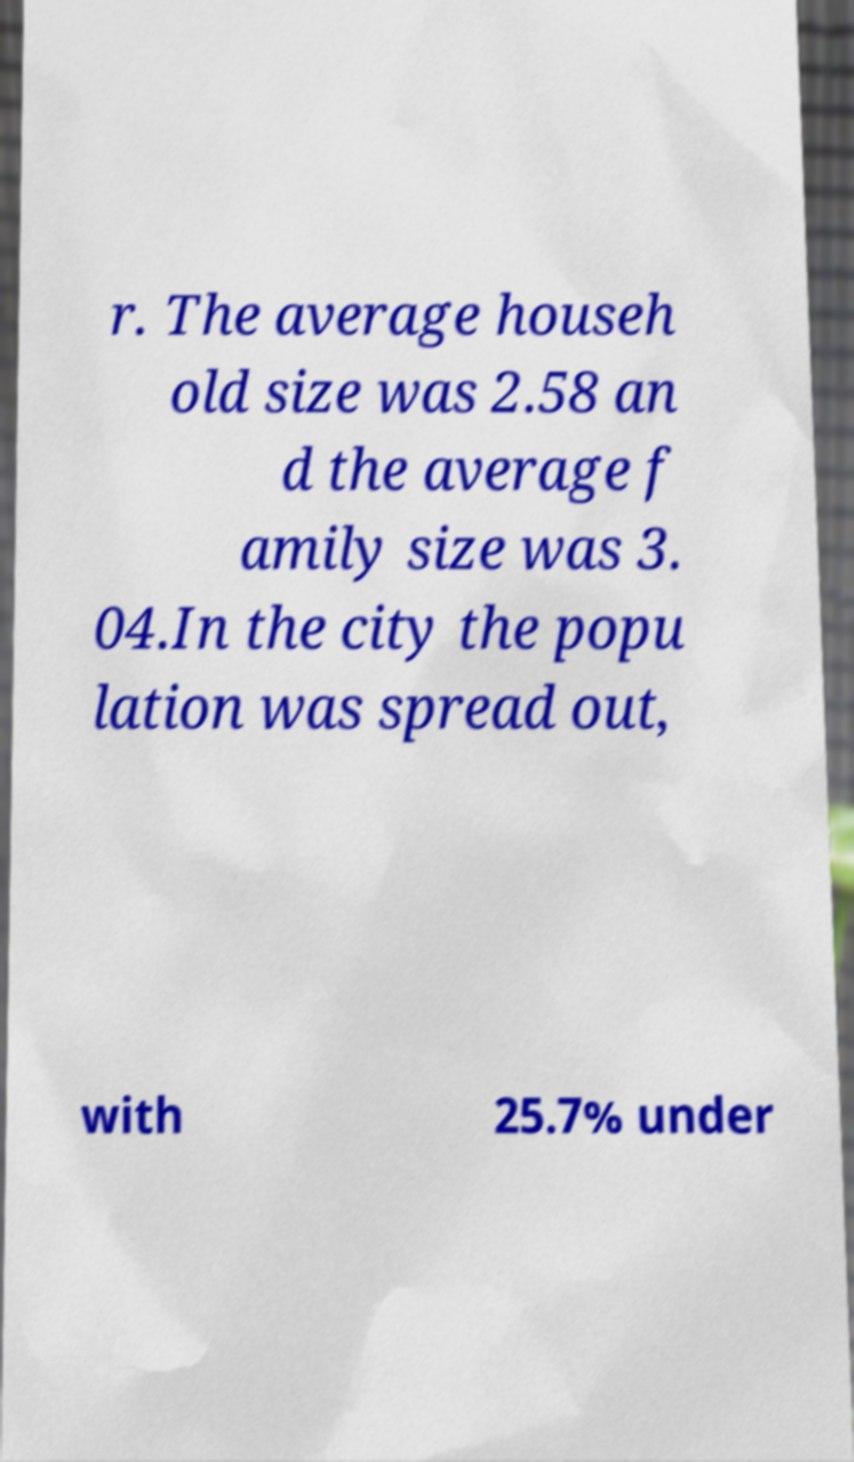What messages or text are displayed in this image? I need them in a readable, typed format. r. The average househ old size was 2.58 an d the average f amily size was 3. 04.In the city the popu lation was spread out, with 25.7% under 